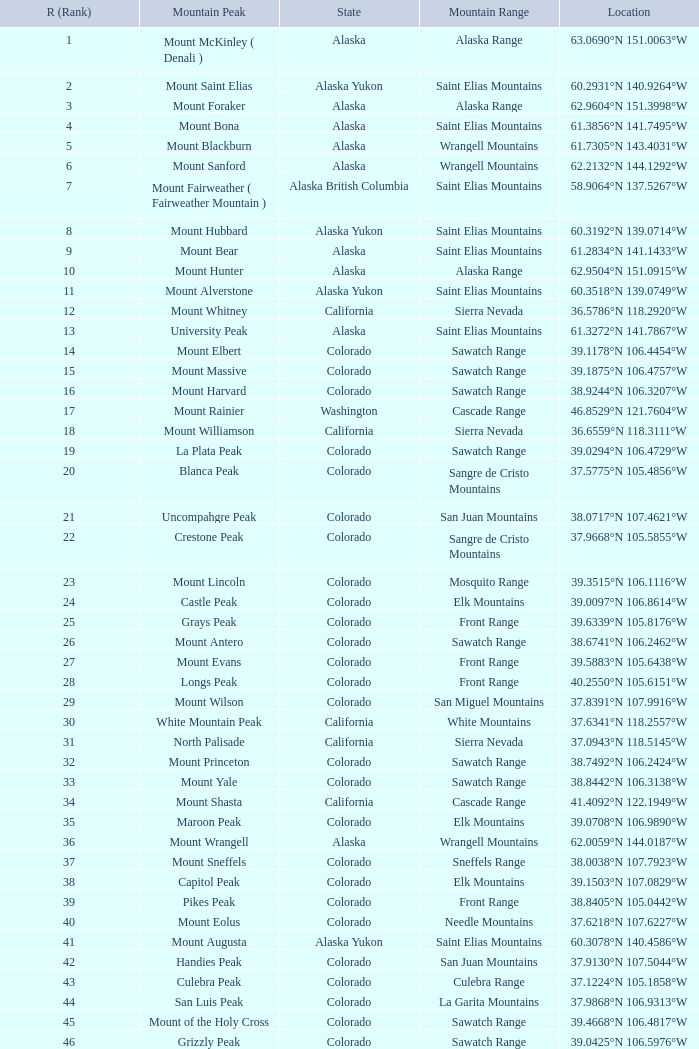What is the mountain range when the state is colorado, rank is higher than 90 and mountain peak is whetstone mountain? West Elk Mountains. 